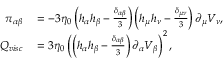<formula> <loc_0><loc_0><loc_500><loc_500>\begin{array} { r l } { \pi _ { \alpha \beta } } & = - 3 \eta _ { 0 } \left ( h _ { \alpha } h _ { \beta } - \frac { \delta _ { \alpha \beta } } { 3 } \right ) \left ( h _ { \mu } h _ { \nu } - \frac { \delta _ { \mu \nu } } { 3 } \right ) \partial _ { \mu } V _ { \nu } , } \\ { Q _ { v i s c } } & = 3 \eta _ { 0 } \left ( \left ( h _ { \alpha } h _ { \beta } - \frac { \delta _ { \alpha \beta } } { 3 } \right ) \partial _ { \alpha } V _ { \beta } \right ) ^ { 2 } , } \end{array}</formula> 